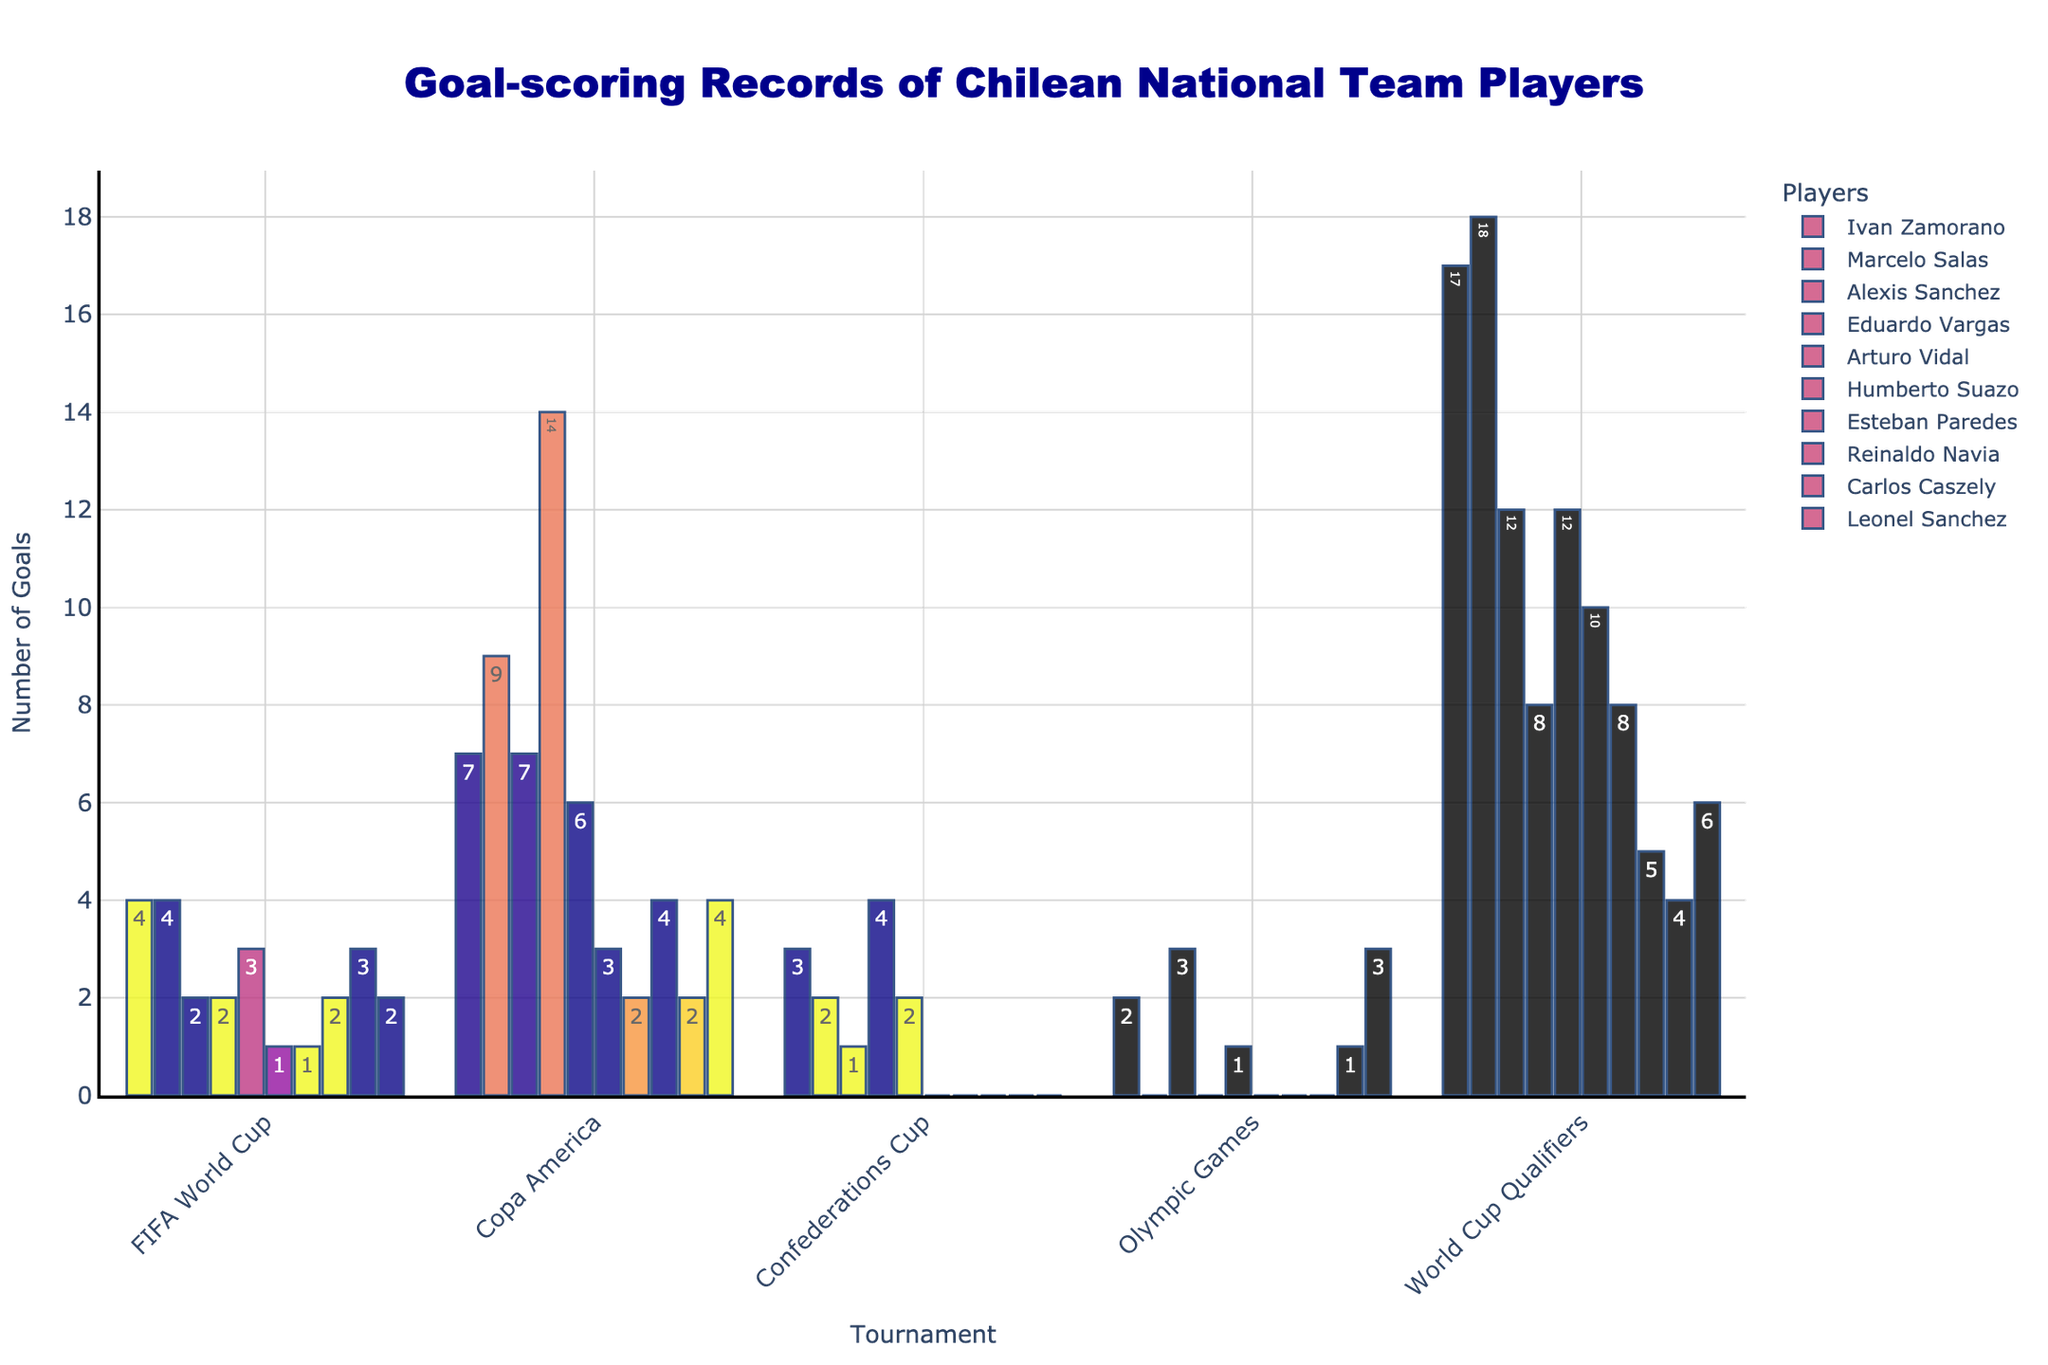How many total goals have Eduardo Vargas and Leonel Sanchez scored in World Cup Qualifiers combined? Eduardo Vargas scored 8 goals and Leonel Sanchez scored 6 goals in World Cup Qualifiers. Adding these up, 8 + 6, the total is 14.
Answer: 14 Which player scored the most goals in Copa America? By looking at the heights of the bars in the 'Copa America' section, Marcelo Salas has the highest bar with 9 goals.
Answer: Marcelo Salas Who has scored more goals in FIFA World Cup, Ivan Zamorano or Arturo Vidal? Ivan Zamorano and Arturo Vidal scored 4 and 3 goals respectively in the FIFA World Cup. 4 is greater than 3, so Ivan Zamorano scored more goals.
Answer: Ivan Zamorano What is the difference in goals scored by Alexis Sanchez and Humberto Suazo in the FIFA World Cup? Alexis Sanchez scored 2 goals and Humberto Suazo scored 1 goal in the FIFA World Cup. The difference is 2 - 1 which equals 1.
Answer: 1 Among the players who have scored in the Confederations Cup, who has the fewest goals? Carlos Caszely, Leonel Sanchez, Esteban Paredes, Reinaldo Navia, and Humberto Suazo have all scored 0 goals in the Confederations Cup. However, Humberto Suazo is the only player among the given names who has scored goals in other categories, making him relevant here.
Answer: Humberto Suazo How many total goals have the players collectively scored in the Olympic Games? Summing up all the goals scored in the Olympic Games: 2 (Ivan Zamorano) + 0 (Marcelo Salas) + 3 (Alexis Sanchez) + 0 (Eduardo Vargas) + 1 (Arturo Vidal) + 0 (Humberto Suazo) + 0 (Esteban Paredes) + 0 (Reinaldo Navia) + 1 (Carlos Caszely) + 3 (Leonel Sanchez) = 10.
Answer: 10 What is the ratio of goals scored by Marcelo Salas to Arturo Vidal in World Cup Qualifiers? Marcelo Salas scored 18 goals and Arturo Vidal scored 12 goals in World Cup Qualifiers. The ratio is 18:12, which can be simplified to 3:2.
Answer: 3:2 